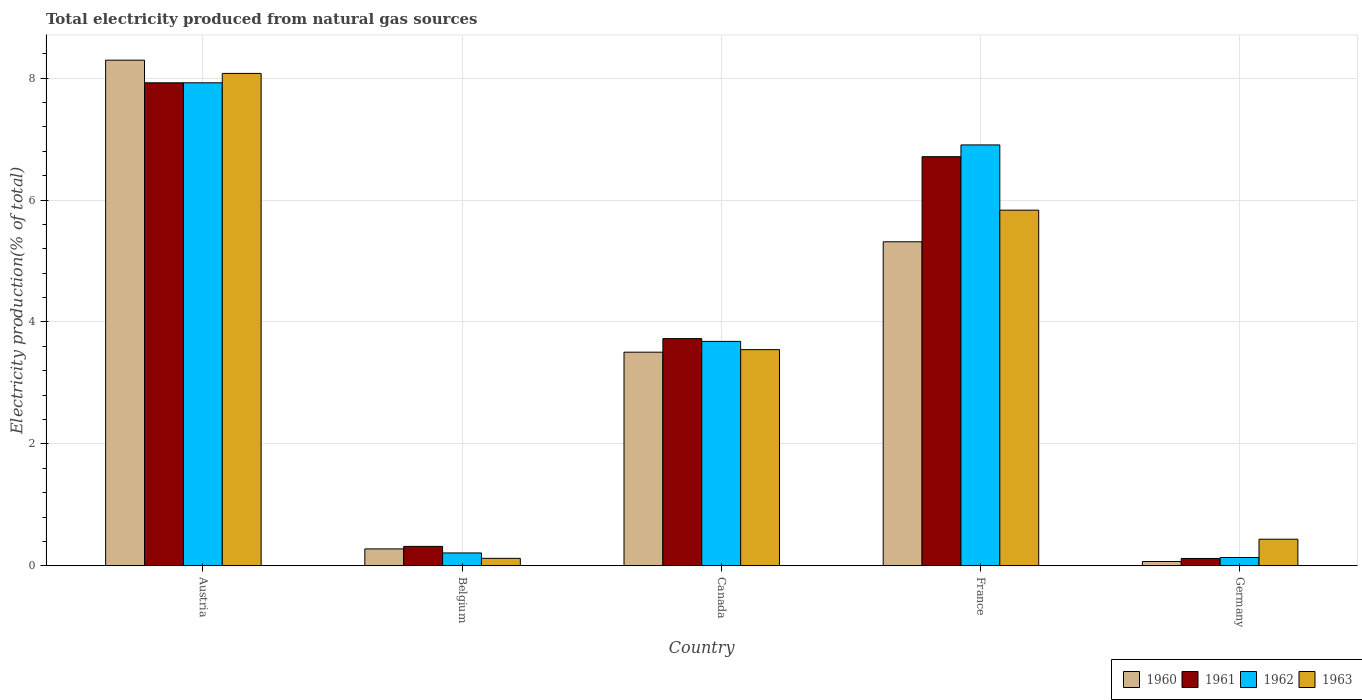How many different coloured bars are there?
Your answer should be very brief. 4. Are the number of bars per tick equal to the number of legend labels?
Your response must be concise. Yes. Are the number of bars on each tick of the X-axis equal?
Your answer should be very brief. Yes. How many bars are there on the 2nd tick from the right?
Give a very brief answer. 4. In how many cases, is the number of bars for a given country not equal to the number of legend labels?
Offer a terse response. 0. What is the total electricity produced in 1963 in Canada?
Provide a succinct answer. 3.55. Across all countries, what is the maximum total electricity produced in 1962?
Give a very brief answer. 7.92. Across all countries, what is the minimum total electricity produced in 1960?
Your response must be concise. 0.07. What is the total total electricity produced in 1962 in the graph?
Your response must be concise. 18.86. What is the difference between the total electricity produced in 1961 in Belgium and that in Germany?
Your answer should be compact. 0.2. What is the difference between the total electricity produced in 1961 in France and the total electricity produced in 1963 in Austria?
Make the answer very short. -1.37. What is the average total electricity produced in 1961 per country?
Give a very brief answer. 3.76. What is the difference between the total electricity produced of/in 1962 and total electricity produced of/in 1961 in Belgium?
Offer a terse response. -0.11. In how many countries, is the total electricity produced in 1963 greater than 6.8 %?
Your answer should be compact. 1. What is the ratio of the total electricity produced in 1960 in Austria to that in Canada?
Your answer should be compact. 2.37. Is the total electricity produced in 1960 in Belgium less than that in France?
Make the answer very short. Yes. Is the difference between the total electricity produced in 1962 in Canada and France greater than the difference between the total electricity produced in 1961 in Canada and France?
Your answer should be very brief. No. What is the difference between the highest and the second highest total electricity produced in 1960?
Your answer should be compact. 4.79. What is the difference between the highest and the lowest total electricity produced in 1961?
Offer a very short reply. 7.8. Is the sum of the total electricity produced in 1961 in Belgium and Canada greater than the maximum total electricity produced in 1963 across all countries?
Keep it short and to the point. No. What does the 2nd bar from the left in Belgium represents?
Make the answer very short. 1961. What does the 2nd bar from the right in France represents?
Your response must be concise. 1962. Is it the case that in every country, the sum of the total electricity produced in 1962 and total electricity produced in 1963 is greater than the total electricity produced in 1961?
Offer a terse response. Yes. Are all the bars in the graph horizontal?
Ensure brevity in your answer.  No. How many countries are there in the graph?
Offer a terse response. 5. What is the difference between two consecutive major ticks on the Y-axis?
Provide a short and direct response. 2. Are the values on the major ticks of Y-axis written in scientific E-notation?
Provide a succinct answer. No. Does the graph contain grids?
Offer a very short reply. Yes. Where does the legend appear in the graph?
Offer a terse response. Bottom right. What is the title of the graph?
Keep it short and to the point. Total electricity produced from natural gas sources. What is the label or title of the X-axis?
Offer a terse response. Country. What is the Electricity production(% of total) in 1960 in Austria?
Offer a terse response. 8.3. What is the Electricity production(% of total) in 1961 in Austria?
Give a very brief answer. 7.92. What is the Electricity production(% of total) of 1962 in Austria?
Your answer should be very brief. 7.92. What is the Electricity production(% of total) of 1963 in Austria?
Keep it short and to the point. 8.08. What is the Electricity production(% of total) of 1960 in Belgium?
Your answer should be compact. 0.28. What is the Electricity production(% of total) in 1961 in Belgium?
Provide a succinct answer. 0.32. What is the Electricity production(% of total) in 1962 in Belgium?
Offer a terse response. 0.21. What is the Electricity production(% of total) of 1963 in Belgium?
Your answer should be very brief. 0.12. What is the Electricity production(% of total) of 1960 in Canada?
Your response must be concise. 3.5. What is the Electricity production(% of total) of 1961 in Canada?
Give a very brief answer. 3.73. What is the Electricity production(% of total) of 1962 in Canada?
Your answer should be compact. 3.68. What is the Electricity production(% of total) in 1963 in Canada?
Provide a short and direct response. 3.55. What is the Electricity production(% of total) in 1960 in France?
Give a very brief answer. 5.32. What is the Electricity production(% of total) of 1961 in France?
Provide a short and direct response. 6.71. What is the Electricity production(% of total) of 1962 in France?
Your answer should be compact. 6.91. What is the Electricity production(% of total) of 1963 in France?
Make the answer very short. 5.83. What is the Electricity production(% of total) of 1960 in Germany?
Your answer should be very brief. 0.07. What is the Electricity production(% of total) in 1961 in Germany?
Offer a very short reply. 0.12. What is the Electricity production(% of total) of 1962 in Germany?
Ensure brevity in your answer.  0.14. What is the Electricity production(% of total) of 1963 in Germany?
Your response must be concise. 0.44. Across all countries, what is the maximum Electricity production(% of total) of 1960?
Your response must be concise. 8.3. Across all countries, what is the maximum Electricity production(% of total) in 1961?
Give a very brief answer. 7.92. Across all countries, what is the maximum Electricity production(% of total) in 1962?
Your answer should be very brief. 7.92. Across all countries, what is the maximum Electricity production(% of total) in 1963?
Offer a very short reply. 8.08. Across all countries, what is the minimum Electricity production(% of total) of 1960?
Your response must be concise. 0.07. Across all countries, what is the minimum Electricity production(% of total) in 1961?
Your answer should be compact. 0.12. Across all countries, what is the minimum Electricity production(% of total) of 1962?
Ensure brevity in your answer.  0.14. Across all countries, what is the minimum Electricity production(% of total) of 1963?
Offer a very short reply. 0.12. What is the total Electricity production(% of total) of 1960 in the graph?
Offer a terse response. 17.46. What is the total Electricity production(% of total) of 1961 in the graph?
Provide a succinct answer. 18.8. What is the total Electricity production(% of total) in 1962 in the graph?
Provide a succinct answer. 18.86. What is the total Electricity production(% of total) in 1963 in the graph?
Your response must be concise. 18.02. What is the difference between the Electricity production(% of total) in 1960 in Austria and that in Belgium?
Your answer should be very brief. 8.02. What is the difference between the Electricity production(% of total) of 1961 in Austria and that in Belgium?
Keep it short and to the point. 7.61. What is the difference between the Electricity production(% of total) in 1962 in Austria and that in Belgium?
Offer a terse response. 7.71. What is the difference between the Electricity production(% of total) in 1963 in Austria and that in Belgium?
Offer a very short reply. 7.96. What is the difference between the Electricity production(% of total) of 1960 in Austria and that in Canada?
Offer a terse response. 4.79. What is the difference between the Electricity production(% of total) of 1961 in Austria and that in Canada?
Give a very brief answer. 4.2. What is the difference between the Electricity production(% of total) in 1962 in Austria and that in Canada?
Your answer should be compact. 4.24. What is the difference between the Electricity production(% of total) in 1963 in Austria and that in Canada?
Your answer should be compact. 4.53. What is the difference between the Electricity production(% of total) of 1960 in Austria and that in France?
Keep it short and to the point. 2.98. What is the difference between the Electricity production(% of total) in 1961 in Austria and that in France?
Offer a very short reply. 1.21. What is the difference between the Electricity production(% of total) in 1962 in Austria and that in France?
Provide a succinct answer. 1.02. What is the difference between the Electricity production(% of total) in 1963 in Austria and that in France?
Ensure brevity in your answer.  2.24. What is the difference between the Electricity production(% of total) of 1960 in Austria and that in Germany?
Provide a succinct answer. 8.23. What is the difference between the Electricity production(% of total) in 1961 in Austria and that in Germany?
Provide a succinct answer. 7.8. What is the difference between the Electricity production(% of total) in 1962 in Austria and that in Germany?
Keep it short and to the point. 7.79. What is the difference between the Electricity production(% of total) in 1963 in Austria and that in Germany?
Offer a terse response. 7.64. What is the difference between the Electricity production(% of total) in 1960 in Belgium and that in Canada?
Ensure brevity in your answer.  -3.23. What is the difference between the Electricity production(% of total) of 1961 in Belgium and that in Canada?
Make the answer very short. -3.41. What is the difference between the Electricity production(% of total) in 1962 in Belgium and that in Canada?
Your response must be concise. -3.47. What is the difference between the Electricity production(% of total) in 1963 in Belgium and that in Canada?
Ensure brevity in your answer.  -3.42. What is the difference between the Electricity production(% of total) in 1960 in Belgium and that in France?
Give a very brief answer. -5.04. What is the difference between the Electricity production(% of total) in 1961 in Belgium and that in France?
Give a very brief answer. -6.39. What is the difference between the Electricity production(% of total) of 1962 in Belgium and that in France?
Provide a succinct answer. -6.69. What is the difference between the Electricity production(% of total) of 1963 in Belgium and that in France?
Provide a succinct answer. -5.71. What is the difference between the Electricity production(% of total) of 1960 in Belgium and that in Germany?
Provide a succinct answer. 0.21. What is the difference between the Electricity production(% of total) in 1961 in Belgium and that in Germany?
Offer a terse response. 0.2. What is the difference between the Electricity production(% of total) in 1962 in Belgium and that in Germany?
Offer a very short reply. 0.07. What is the difference between the Electricity production(% of total) of 1963 in Belgium and that in Germany?
Your answer should be compact. -0.31. What is the difference between the Electricity production(% of total) in 1960 in Canada and that in France?
Offer a very short reply. -1.81. What is the difference between the Electricity production(% of total) of 1961 in Canada and that in France?
Your answer should be compact. -2.99. What is the difference between the Electricity production(% of total) in 1962 in Canada and that in France?
Offer a terse response. -3.22. What is the difference between the Electricity production(% of total) in 1963 in Canada and that in France?
Your answer should be very brief. -2.29. What is the difference between the Electricity production(% of total) of 1960 in Canada and that in Germany?
Offer a terse response. 3.43. What is the difference between the Electricity production(% of total) in 1961 in Canada and that in Germany?
Make the answer very short. 3.61. What is the difference between the Electricity production(% of total) in 1962 in Canada and that in Germany?
Provide a succinct answer. 3.55. What is the difference between the Electricity production(% of total) in 1963 in Canada and that in Germany?
Give a very brief answer. 3.11. What is the difference between the Electricity production(% of total) in 1960 in France and that in Germany?
Keep it short and to the point. 5.25. What is the difference between the Electricity production(% of total) in 1961 in France and that in Germany?
Provide a succinct answer. 6.59. What is the difference between the Electricity production(% of total) of 1962 in France and that in Germany?
Offer a very short reply. 6.77. What is the difference between the Electricity production(% of total) in 1963 in France and that in Germany?
Give a very brief answer. 5.4. What is the difference between the Electricity production(% of total) in 1960 in Austria and the Electricity production(% of total) in 1961 in Belgium?
Your response must be concise. 7.98. What is the difference between the Electricity production(% of total) in 1960 in Austria and the Electricity production(% of total) in 1962 in Belgium?
Offer a terse response. 8.08. What is the difference between the Electricity production(% of total) in 1960 in Austria and the Electricity production(% of total) in 1963 in Belgium?
Give a very brief answer. 8.17. What is the difference between the Electricity production(% of total) in 1961 in Austria and the Electricity production(% of total) in 1962 in Belgium?
Your answer should be very brief. 7.71. What is the difference between the Electricity production(% of total) of 1961 in Austria and the Electricity production(% of total) of 1963 in Belgium?
Your response must be concise. 7.8. What is the difference between the Electricity production(% of total) of 1962 in Austria and the Electricity production(% of total) of 1963 in Belgium?
Keep it short and to the point. 7.8. What is the difference between the Electricity production(% of total) of 1960 in Austria and the Electricity production(% of total) of 1961 in Canada?
Provide a succinct answer. 4.57. What is the difference between the Electricity production(% of total) of 1960 in Austria and the Electricity production(% of total) of 1962 in Canada?
Provide a succinct answer. 4.61. What is the difference between the Electricity production(% of total) in 1960 in Austria and the Electricity production(% of total) in 1963 in Canada?
Offer a very short reply. 4.75. What is the difference between the Electricity production(% of total) in 1961 in Austria and the Electricity production(% of total) in 1962 in Canada?
Provide a succinct answer. 4.24. What is the difference between the Electricity production(% of total) in 1961 in Austria and the Electricity production(% of total) in 1963 in Canada?
Your answer should be very brief. 4.38. What is the difference between the Electricity production(% of total) in 1962 in Austria and the Electricity production(% of total) in 1963 in Canada?
Provide a short and direct response. 4.38. What is the difference between the Electricity production(% of total) in 1960 in Austria and the Electricity production(% of total) in 1961 in France?
Your answer should be compact. 1.58. What is the difference between the Electricity production(% of total) of 1960 in Austria and the Electricity production(% of total) of 1962 in France?
Give a very brief answer. 1.39. What is the difference between the Electricity production(% of total) in 1960 in Austria and the Electricity production(% of total) in 1963 in France?
Your answer should be very brief. 2.46. What is the difference between the Electricity production(% of total) of 1961 in Austria and the Electricity production(% of total) of 1962 in France?
Give a very brief answer. 1.02. What is the difference between the Electricity production(% of total) in 1961 in Austria and the Electricity production(% of total) in 1963 in France?
Ensure brevity in your answer.  2.09. What is the difference between the Electricity production(% of total) in 1962 in Austria and the Electricity production(% of total) in 1963 in France?
Keep it short and to the point. 2.09. What is the difference between the Electricity production(% of total) in 1960 in Austria and the Electricity production(% of total) in 1961 in Germany?
Provide a succinct answer. 8.18. What is the difference between the Electricity production(% of total) of 1960 in Austria and the Electricity production(% of total) of 1962 in Germany?
Your response must be concise. 8.16. What is the difference between the Electricity production(% of total) of 1960 in Austria and the Electricity production(% of total) of 1963 in Germany?
Ensure brevity in your answer.  7.86. What is the difference between the Electricity production(% of total) of 1961 in Austria and the Electricity production(% of total) of 1962 in Germany?
Your answer should be very brief. 7.79. What is the difference between the Electricity production(% of total) in 1961 in Austria and the Electricity production(% of total) in 1963 in Germany?
Keep it short and to the point. 7.49. What is the difference between the Electricity production(% of total) in 1962 in Austria and the Electricity production(% of total) in 1963 in Germany?
Provide a short and direct response. 7.49. What is the difference between the Electricity production(% of total) in 1960 in Belgium and the Electricity production(% of total) in 1961 in Canada?
Make the answer very short. -3.45. What is the difference between the Electricity production(% of total) in 1960 in Belgium and the Electricity production(% of total) in 1962 in Canada?
Provide a short and direct response. -3.4. What is the difference between the Electricity production(% of total) of 1960 in Belgium and the Electricity production(% of total) of 1963 in Canada?
Offer a terse response. -3.27. What is the difference between the Electricity production(% of total) of 1961 in Belgium and the Electricity production(% of total) of 1962 in Canada?
Offer a terse response. -3.36. What is the difference between the Electricity production(% of total) in 1961 in Belgium and the Electricity production(% of total) in 1963 in Canada?
Your answer should be very brief. -3.23. What is the difference between the Electricity production(% of total) of 1962 in Belgium and the Electricity production(% of total) of 1963 in Canada?
Give a very brief answer. -3.34. What is the difference between the Electricity production(% of total) in 1960 in Belgium and the Electricity production(% of total) in 1961 in France?
Offer a terse response. -6.43. What is the difference between the Electricity production(% of total) in 1960 in Belgium and the Electricity production(% of total) in 1962 in France?
Provide a short and direct response. -6.63. What is the difference between the Electricity production(% of total) of 1960 in Belgium and the Electricity production(% of total) of 1963 in France?
Offer a very short reply. -5.56. What is the difference between the Electricity production(% of total) of 1961 in Belgium and the Electricity production(% of total) of 1962 in France?
Offer a very short reply. -6.59. What is the difference between the Electricity production(% of total) of 1961 in Belgium and the Electricity production(% of total) of 1963 in France?
Keep it short and to the point. -5.52. What is the difference between the Electricity production(% of total) of 1962 in Belgium and the Electricity production(% of total) of 1963 in France?
Your answer should be very brief. -5.62. What is the difference between the Electricity production(% of total) in 1960 in Belgium and the Electricity production(% of total) in 1961 in Germany?
Give a very brief answer. 0.16. What is the difference between the Electricity production(% of total) of 1960 in Belgium and the Electricity production(% of total) of 1962 in Germany?
Provide a succinct answer. 0.14. What is the difference between the Electricity production(% of total) of 1960 in Belgium and the Electricity production(% of total) of 1963 in Germany?
Provide a succinct answer. -0.16. What is the difference between the Electricity production(% of total) in 1961 in Belgium and the Electricity production(% of total) in 1962 in Germany?
Your answer should be very brief. 0.18. What is the difference between the Electricity production(% of total) in 1961 in Belgium and the Electricity production(% of total) in 1963 in Germany?
Keep it short and to the point. -0.12. What is the difference between the Electricity production(% of total) in 1962 in Belgium and the Electricity production(% of total) in 1963 in Germany?
Keep it short and to the point. -0.23. What is the difference between the Electricity production(% of total) of 1960 in Canada and the Electricity production(% of total) of 1961 in France?
Ensure brevity in your answer.  -3.21. What is the difference between the Electricity production(% of total) in 1960 in Canada and the Electricity production(% of total) in 1962 in France?
Provide a short and direct response. -3.4. What is the difference between the Electricity production(% of total) of 1960 in Canada and the Electricity production(% of total) of 1963 in France?
Make the answer very short. -2.33. What is the difference between the Electricity production(% of total) in 1961 in Canada and the Electricity production(% of total) in 1962 in France?
Offer a very short reply. -3.18. What is the difference between the Electricity production(% of total) of 1961 in Canada and the Electricity production(% of total) of 1963 in France?
Provide a short and direct response. -2.11. What is the difference between the Electricity production(% of total) in 1962 in Canada and the Electricity production(% of total) in 1963 in France?
Offer a terse response. -2.15. What is the difference between the Electricity production(% of total) in 1960 in Canada and the Electricity production(% of total) in 1961 in Germany?
Provide a short and direct response. 3.38. What is the difference between the Electricity production(% of total) in 1960 in Canada and the Electricity production(% of total) in 1962 in Germany?
Make the answer very short. 3.37. What is the difference between the Electricity production(% of total) in 1960 in Canada and the Electricity production(% of total) in 1963 in Germany?
Provide a succinct answer. 3.07. What is the difference between the Electricity production(% of total) of 1961 in Canada and the Electricity production(% of total) of 1962 in Germany?
Offer a terse response. 3.59. What is the difference between the Electricity production(% of total) in 1961 in Canada and the Electricity production(% of total) in 1963 in Germany?
Your response must be concise. 3.29. What is the difference between the Electricity production(% of total) in 1962 in Canada and the Electricity production(% of total) in 1963 in Germany?
Provide a succinct answer. 3.25. What is the difference between the Electricity production(% of total) of 1960 in France and the Electricity production(% of total) of 1961 in Germany?
Keep it short and to the point. 5.2. What is the difference between the Electricity production(% of total) in 1960 in France and the Electricity production(% of total) in 1962 in Germany?
Make the answer very short. 5.18. What is the difference between the Electricity production(% of total) of 1960 in France and the Electricity production(% of total) of 1963 in Germany?
Make the answer very short. 4.88. What is the difference between the Electricity production(% of total) of 1961 in France and the Electricity production(% of total) of 1962 in Germany?
Provide a succinct answer. 6.58. What is the difference between the Electricity production(% of total) in 1961 in France and the Electricity production(% of total) in 1963 in Germany?
Keep it short and to the point. 6.28. What is the difference between the Electricity production(% of total) in 1962 in France and the Electricity production(% of total) in 1963 in Germany?
Offer a terse response. 6.47. What is the average Electricity production(% of total) of 1960 per country?
Ensure brevity in your answer.  3.49. What is the average Electricity production(% of total) in 1961 per country?
Your response must be concise. 3.76. What is the average Electricity production(% of total) of 1962 per country?
Offer a terse response. 3.77. What is the average Electricity production(% of total) of 1963 per country?
Provide a short and direct response. 3.6. What is the difference between the Electricity production(% of total) in 1960 and Electricity production(% of total) in 1961 in Austria?
Your response must be concise. 0.37. What is the difference between the Electricity production(% of total) in 1960 and Electricity production(% of total) in 1962 in Austria?
Make the answer very short. 0.37. What is the difference between the Electricity production(% of total) in 1960 and Electricity production(% of total) in 1963 in Austria?
Provide a succinct answer. 0.22. What is the difference between the Electricity production(% of total) of 1961 and Electricity production(% of total) of 1963 in Austria?
Make the answer very short. -0.15. What is the difference between the Electricity production(% of total) of 1962 and Electricity production(% of total) of 1963 in Austria?
Offer a terse response. -0.15. What is the difference between the Electricity production(% of total) of 1960 and Electricity production(% of total) of 1961 in Belgium?
Give a very brief answer. -0.04. What is the difference between the Electricity production(% of total) of 1960 and Electricity production(% of total) of 1962 in Belgium?
Ensure brevity in your answer.  0.07. What is the difference between the Electricity production(% of total) of 1960 and Electricity production(% of total) of 1963 in Belgium?
Your response must be concise. 0.15. What is the difference between the Electricity production(% of total) of 1961 and Electricity production(% of total) of 1962 in Belgium?
Keep it short and to the point. 0.11. What is the difference between the Electricity production(% of total) in 1961 and Electricity production(% of total) in 1963 in Belgium?
Your answer should be compact. 0.2. What is the difference between the Electricity production(% of total) in 1962 and Electricity production(% of total) in 1963 in Belgium?
Offer a very short reply. 0.09. What is the difference between the Electricity production(% of total) of 1960 and Electricity production(% of total) of 1961 in Canada?
Ensure brevity in your answer.  -0.22. What is the difference between the Electricity production(% of total) in 1960 and Electricity production(% of total) in 1962 in Canada?
Keep it short and to the point. -0.18. What is the difference between the Electricity production(% of total) in 1960 and Electricity production(% of total) in 1963 in Canada?
Make the answer very short. -0.04. What is the difference between the Electricity production(% of total) in 1961 and Electricity production(% of total) in 1962 in Canada?
Offer a terse response. 0.05. What is the difference between the Electricity production(% of total) in 1961 and Electricity production(% of total) in 1963 in Canada?
Keep it short and to the point. 0.18. What is the difference between the Electricity production(% of total) of 1962 and Electricity production(% of total) of 1963 in Canada?
Offer a very short reply. 0.14. What is the difference between the Electricity production(% of total) of 1960 and Electricity production(% of total) of 1961 in France?
Your answer should be very brief. -1.4. What is the difference between the Electricity production(% of total) in 1960 and Electricity production(% of total) in 1962 in France?
Your answer should be very brief. -1.59. What is the difference between the Electricity production(% of total) of 1960 and Electricity production(% of total) of 1963 in France?
Your answer should be very brief. -0.52. What is the difference between the Electricity production(% of total) in 1961 and Electricity production(% of total) in 1962 in France?
Give a very brief answer. -0.19. What is the difference between the Electricity production(% of total) of 1961 and Electricity production(% of total) of 1963 in France?
Provide a short and direct response. 0.88. What is the difference between the Electricity production(% of total) of 1962 and Electricity production(% of total) of 1963 in France?
Provide a succinct answer. 1.07. What is the difference between the Electricity production(% of total) of 1960 and Electricity production(% of total) of 1962 in Germany?
Offer a terse response. -0.07. What is the difference between the Electricity production(% of total) in 1960 and Electricity production(% of total) in 1963 in Germany?
Offer a very short reply. -0.37. What is the difference between the Electricity production(% of total) in 1961 and Electricity production(% of total) in 1962 in Germany?
Ensure brevity in your answer.  -0.02. What is the difference between the Electricity production(% of total) in 1961 and Electricity production(% of total) in 1963 in Germany?
Your answer should be compact. -0.32. What is the difference between the Electricity production(% of total) of 1962 and Electricity production(% of total) of 1963 in Germany?
Your answer should be very brief. -0.3. What is the ratio of the Electricity production(% of total) of 1960 in Austria to that in Belgium?
Provide a succinct answer. 29.93. What is the ratio of the Electricity production(% of total) of 1961 in Austria to that in Belgium?
Offer a very short reply. 24.9. What is the ratio of the Electricity production(% of total) of 1962 in Austria to that in Belgium?
Your answer should be compact. 37.57. What is the ratio of the Electricity production(% of total) of 1963 in Austria to that in Belgium?
Your answer should be compact. 66.07. What is the ratio of the Electricity production(% of total) in 1960 in Austria to that in Canada?
Your response must be concise. 2.37. What is the ratio of the Electricity production(% of total) in 1961 in Austria to that in Canada?
Give a very brief answer. 2.13. What is the ratio of the Electricity production(% of total) in 1962 in Austria to that in Canada?
Offer a very short reply. 2.15. What is the ratio of the Electricity production(% of total) of 1963 in Austria to that in Canada?
Offer a very short reply. 2.28. What is the ratio of the Electricity production(% of total) of 1960 in Austria to that in France?
Offer a terse response. 1.56. What is the ratio of the Electricity production(% of total) of 1961 in Austria to that in France?
Provide a succinct answer. 1.18. What is the ratio of the Electricity production(% of total) in 1962 in Austria to that in France?
Ensure brevity in your answer.  1.15. What is the ratio of the Electricity production(% of total) of 1963 in Austria to that in France?
Make the answer very short. 1.38. What is the ratio of the Electricity production(% of total) in 1960 in Austria to that in Germany?
Offer a very short reply. 118.01. What is the ratio of the Electricity production(% of total) in 1961 in Austria to that in Germany?
Offer a terse response. 65.86. What is the ratio of the Electricity production(% of total) in 1962 in Austria to that in Germany?
Your response must be concise. 58.17. What is the ratio of the Electricity production(% of total) of 1963 in Austria to that in Germany?
Provide a succinct answer. 18.52. What is the ratio of the Electricity production(% of total) in 1960 in Belgium to that in Canada?
Offer a very short reply. 0.08. What is the ratio of the Electricity production(% of total) in 1961 in Belgium to that in Canada?
Your response must be concise. 0.09. What is the ratio of the Electricity production(% of total) of 1962 in Belgium to that in Canada?
Your answer should be very brief. 0.06. What is the ratio of the Electricity production(% of total) of 1963 in Belgium to that in Canada?
Keep it short and to the point. 0.03. What is the ratio of the Electricity production(% of total) in 1960 in Belgium to that in France?
Keep it short and to the point. 0.05. What is the ratio of the Electricity production(% of total) in 1961 in Belgium to that in France?
Provide a succinct answer. 0.05. What is the ratio of the Electricity production(% of total) of 1962 in Belgium to that in France?
Offer a very short reply. 0.03. What is the ratio of the Electricity production(% of total) of 1963 in Belgium to that in France?
Provide a short and direct response. 0.02. What is the ratio of the Electricity production(% of total) in 1960 in Belgium to that in Germany?
Keep it short and to the point. 3.94. What is the ratio of the Electricity production(% of total) of 1961 in Belgium to that in Germany?
Make the answer very short. 2.64. What is the ratio of the Electricity production(% of total) in 1962 in Belgium to that in Germany?
Offer a very short reply. 1.55. What is the ratio of the Electricity production(% of total) in 1963 in Belgium to that in Germany?
Your answer should be very brief. 0.28. What is the ratio of the Electricity production(% of total) in 1960 in Canada to that in France?
Provide a short and direct response. 0.66. What is the ratio of the Electricity production(% of total) of 1961 in Canada to that in France?
Provide a succinct answer. 0.56. What is the ratio of the Electricity production(% of total) in 1962 in Canada to that in France?
Ensure brevity in your answer.  0.53. What is the ratio of the Electricity production(% of total) in 1963 in Canada to that in France?
Make the answer very short. 0.61. What is the ratio of the Electricity production(% of total) in 1960 in Canada to that in Germany?
Offer a very short reply. 49.85. What is the ratio of the Electricity production(% of total) of 1961 in Canada to that in Germany?
Your response must be concise. 30.98. What is the ratio of the Electricity production(% of total) of 1962 in Canada to that in Germany?
Keep it short and to the point. 27.02. What is the ratio of the Electricity production(% of total) in 1963 in Canada to that in Germany?
Make the answer very short. 8.13. What is the ratio of the Electricity production(% of total) of 1960 in France to that in Germany?
Your response must be concise. 75.62. What is the ratio of the Electricity production(% of total) of 1961 in France to that in Germany?
Provide a short and direct response. 55.79. What is the ratio of the Electricity production(% of total) in 1962 in France to that in Germany?
Keep it short and to the point. 50.69. What is the ratio of the Electricity production(% of total) in 1963 in France to that in Germany?
Offer a terse response. 13.38. What is the difference between the highest and the second highest Electricity production(% of total) in 1960?
Keep it short and to the point. 2.98. What is the difference between the highest and the second highest Electricity production(% of total) of 1961?
Your response must be concise. 1.21. What is the difference between the highest and the second highest Electricity production(% of total) of 1962?
Give a very brief answer. 1.02. What is the difference between the highest and the second highest Electricity production(% of total) in 1963?
Your answer should be compact. 2.24. What is the difference between the highest and the lowest Electricity production(% of total) in 1960?
Your answer should be compact. 8.23. What is the difference between the highest and the lowest Electricity production(% of total) in 1961?
Ensure brevity in your answer.  7.8. What is the difference between the highest and the lowest Electricity production(% of total) in 1962?
Provide a short and direct response. 7.79. What is the difference between the highest and the lowest Electricity production(% of total) of 1963?
Ensure brevity in your answer.  7.96. 